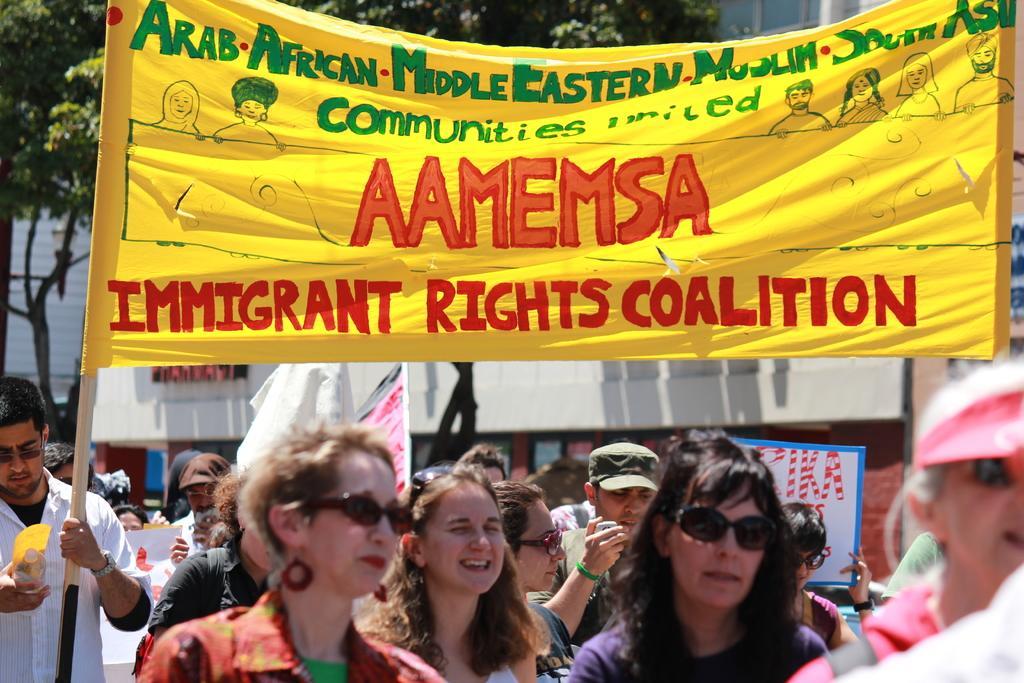Could you give a brief overview of what you see in this image? In this image I can see group of people walking. I can also see few persons holding banners, in front the banner is in yellow color and something written on it. Background I can see trees in green color. 